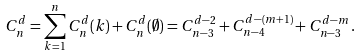Convert formula to latex. <formula><loc_0><loc_0><loc_500><loc_500>C ^ { d } _ { n } = \sum ^ { n } _ { k = 1 } C ^ { d } _ { n } ( k ) + C ^ { d } _ { n } ( \emptyset ) = C ^ { d - 2 } _ { n - 3 } + C ^ { d - ( m + 1 ) } _ { n - 4 } + C ^ { d - m } _ { n - 3 } \, .</formula> 